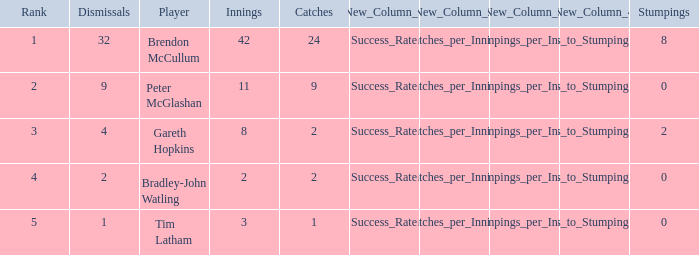How many stumpings did the player Tim Latham have? 0.0. 